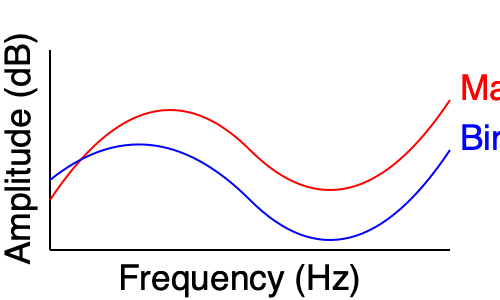Based on the frequency response curves shown for maple and birch drum shells, which material would likely produce a brighter overall sound with more pronounced high frequencies? To determine which material produces a brighter sound with more pronounced high frequencies, we need to analyze the frequency response curves:

1. Observe the curves:
   - Red curve represents maple
   - Blue curve represents birch

2. Analyze the high-frequency region (right side of the graph):
   - Maple (red) curve shows higher amplitude in the high-frequency range
   - Birch (blue) curve shows lower amplitude in the high-frequency range

3. Understand the relationship between frequency response and perceived sound:
   - Higher amplitude in high frequencies correlates with a brighter sound
   - More energy in high frequencies results in more pronounced high-frequency content

4. Compare the overall shape of the curves:
   - Maple curve has a more pronounced peak in the high-frequency region
   - Birch curve is more balanced across the frequency spectrum

5. Consider the acoustic properties of wood:
   - Maple is known for its ability to reflect high frequencies efficiently
   - Birch tends to have a more balanced frequency response

6. Conclusion:
   Based on the frequency response curves, maple would likely produce a brighter overall sound with more pronounced high frequencies due to its higher amplitude in the high-frequency range.
Answer: Maple 